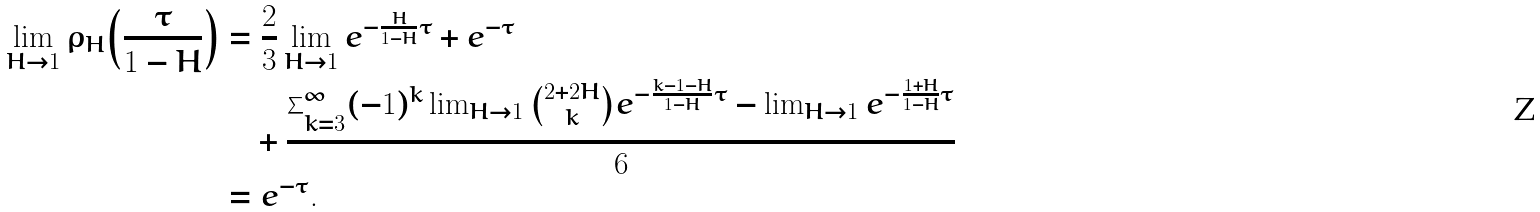<formula> <loc_0><loc_0><loc_500><loc_500>\lim _ { H \to 1 } \rho _ { H } { \left ( \frac { \tau } { 1 - H } \right ) } & = \frac { 2 } { 3 } \lim _ { H \to 1 } e ^ { - \frac { H } { 1 - H } \tau } + e ^ { - \tau } \\ & \quad + \frac { \sum _ { k = 3 } ^ { \infty } ( - 1 ) ^ { k } \lim _ { H \to 1 } \binom { 2 + 2 H } { k } e ^ { - \frac { k - 1 - H } { 1 - H } \tau } - \lim _ { H \to 1 } e ^ { - \frac { 1 + H } { 1 - H } \tau } } { 6 } \\ & = e ^ { - \tau } .</formula> 